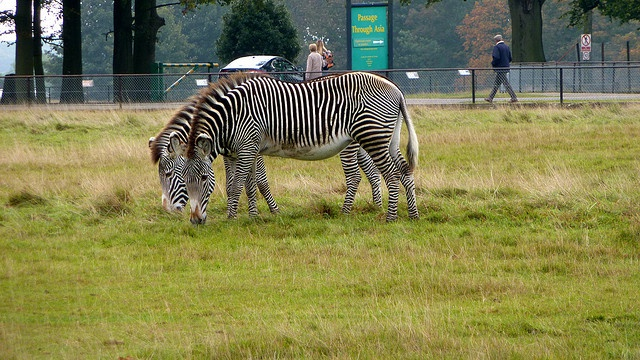Describe the objects in this image and their specific colors. I can see zebra in white, black, gray, ivory, and darkgray tones, zebra in white, black, gray, tan, and darkgray tones, car in white, black, gray, and navy tones, people in white, gray, black, navy, and darkblue tones, and people in white, darkgray, gray, and lightgray tones in this image. 